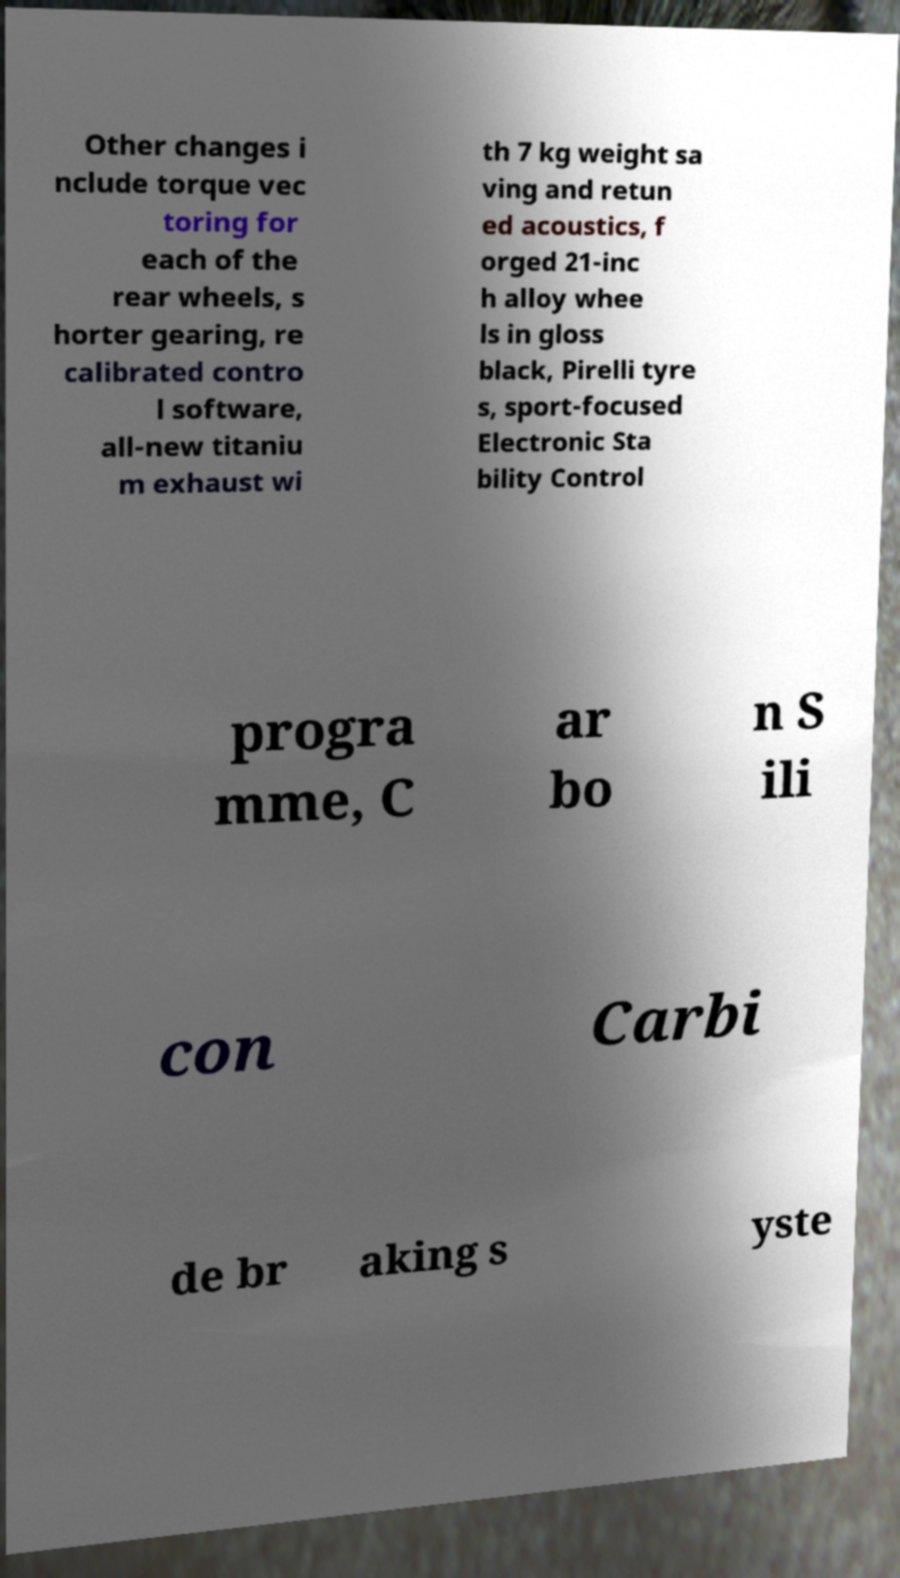I need the written content from this picture converted into text. Can you do that? Other changes i nclude torque vec toring for each of the rear wheels, s horter gearing, re calibrated contro l software, all-new titaniu m exhaust wi th 7 kg weight sa ving and retun ed acoustics, f orged 21-inc h alloy whee ls in gloss black, Pirelli tyre s, sport-focused Electronic Sta bility Control progra mme, C ar bo n S ili con Carbi de br aking s yste 